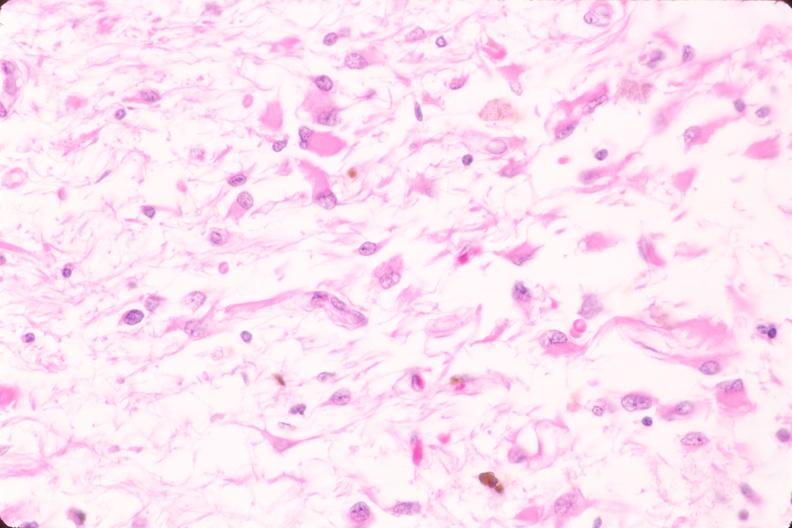s nervous present?
Answer the question using a single word or phrase. Yes 